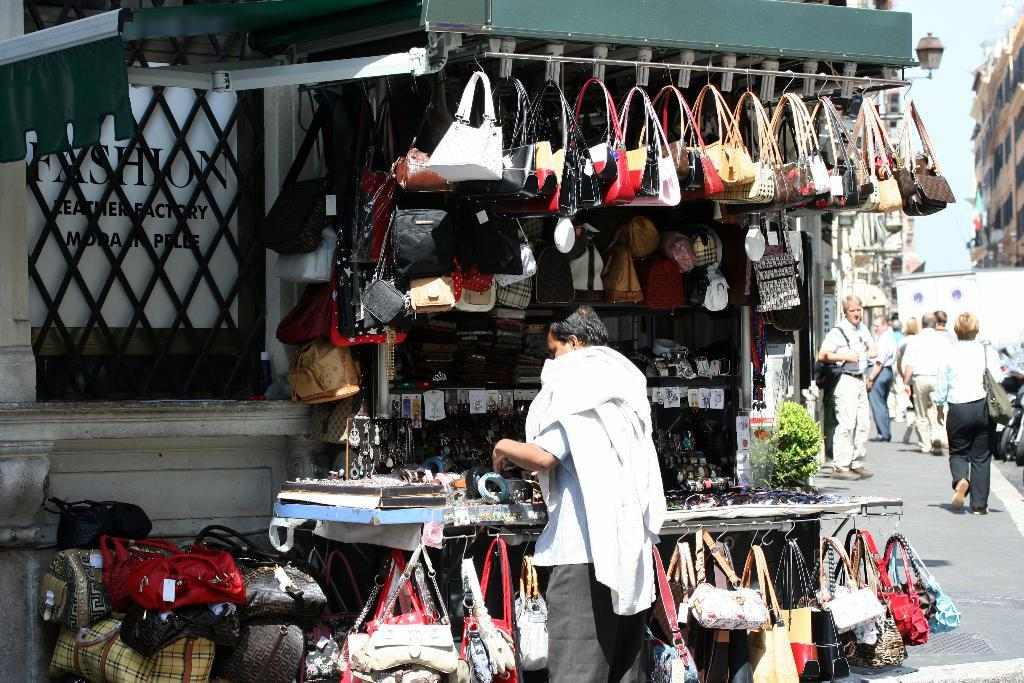What objects can be seen in the image? There are bags, a table, a stall, a plant, a board, and a road in the image. What type of structure is present in the image? There are buildings in the image. Are there any living organisms in the image? Yes, there are people in the image. What is visible in the background of the image? The sky is visible in the image. How many chairs are visible in the image? There are no chairs present in the image. What type of passenger is shown waiting for a ride in the image? There is no passenger waiting for a ride in the image. 